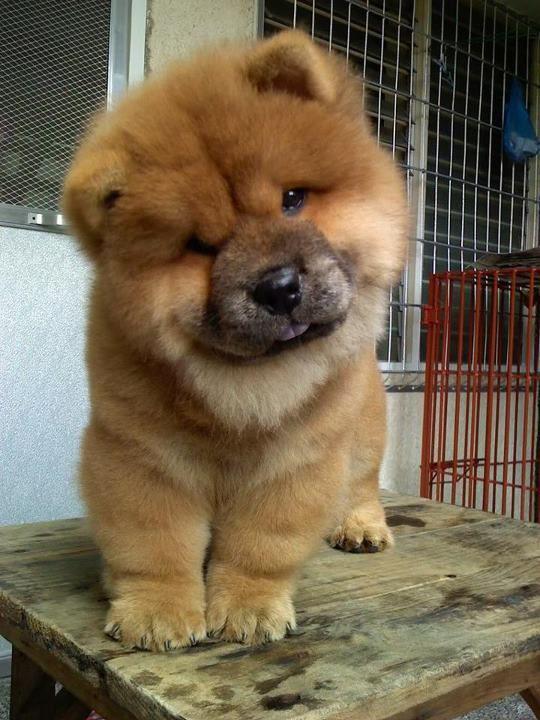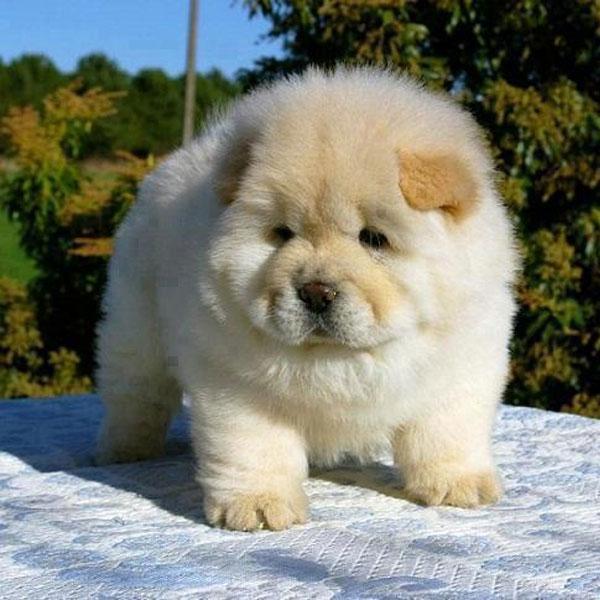The first image is the image on the left, the second image is the image on the right. Assess this claim about the two images: "The right image shows a pale cream-colored chow pup standing on all fours.". Correct or not? Answer yes or no. Yes. 